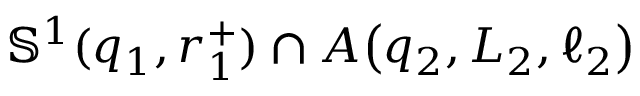Convert formula to latex. <formula><loc_0><loc_0><loc_500><loc_500>\mathbb { S } ^ { 1 } ( q _ { 1 } , r _ { 1 } ^ { + } ) \cap A \, \left ( q _ { 2 } , L _ { 2 } , \ell _ { 2 } \right )</formula> 